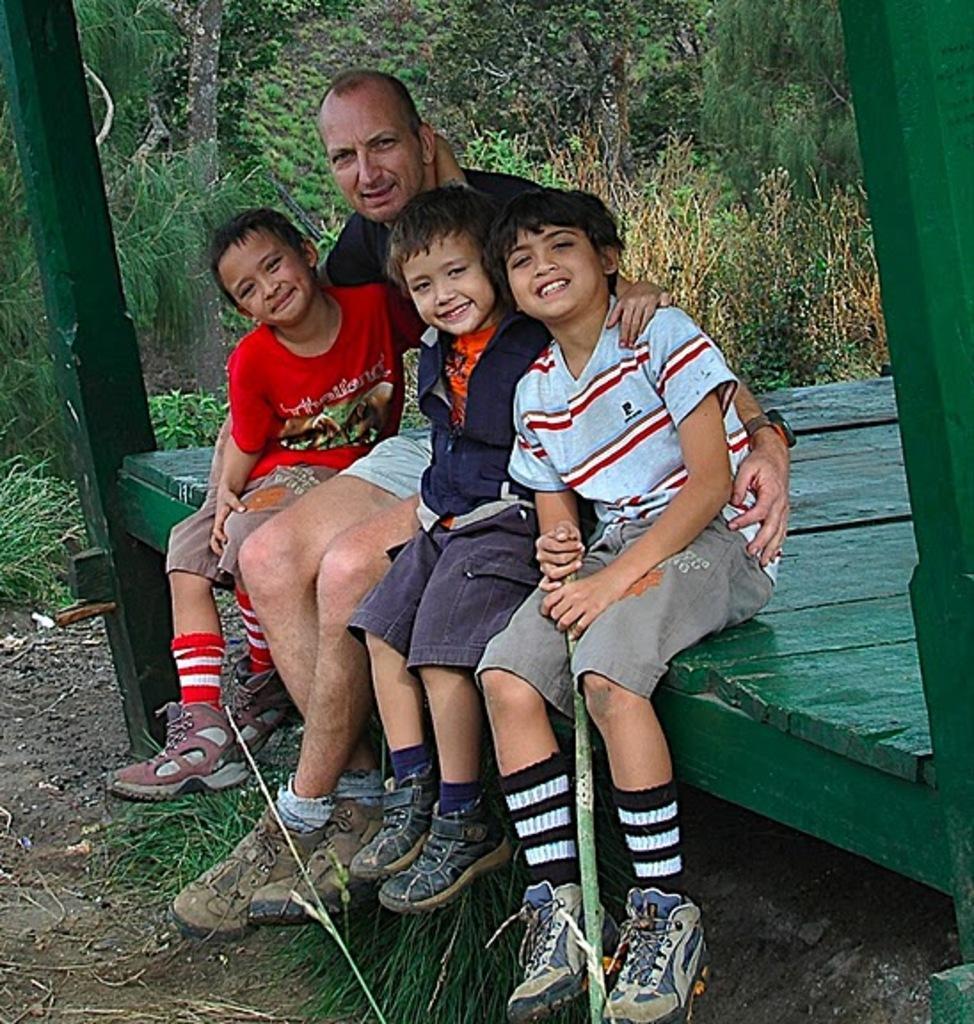Describe this image in one or two sentences. This picture is clicked outside. On the right we can see the three kids and a person sitting on a green color object. In the background we can see the grass and plants. 